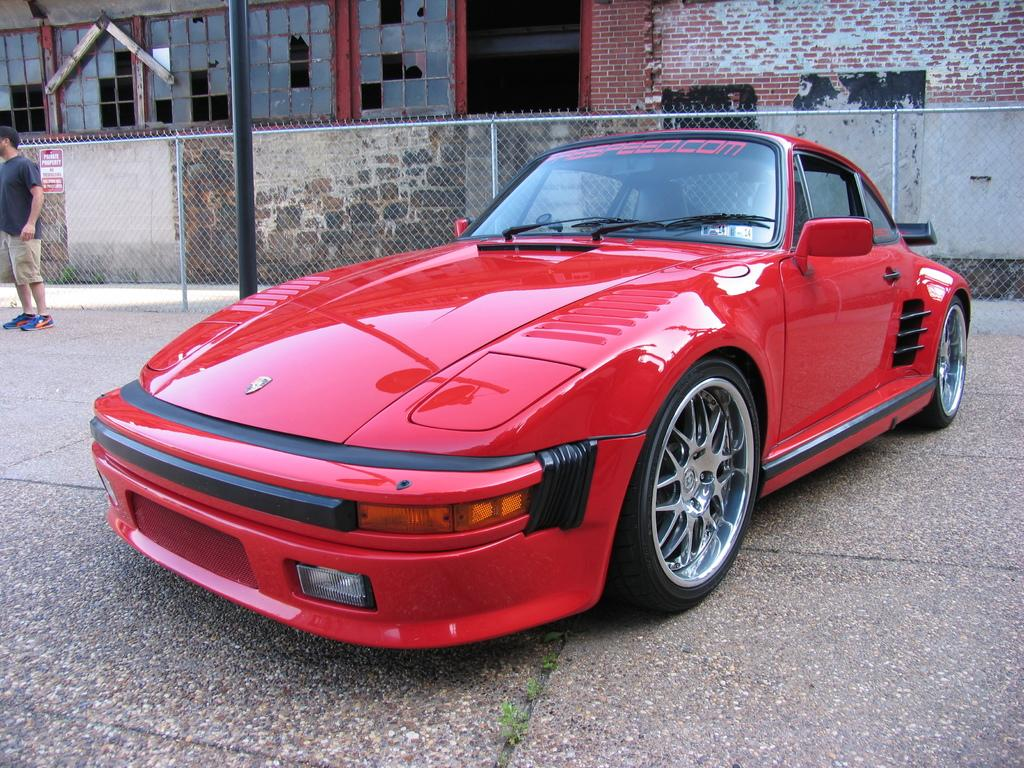What is the main subject in the center of the image? There is a red color car in the center of the image. Where is the car located? The car is on the floor. What can be seen on the left side of the image? There is a person standing on the left side of the image. What is visible in the background of the image? There are buildings, fencing, and a pole in the background of the image. What type of fear does the manager have in the image? There is no manager present in the image, and therefore no fear can be attributed to them. 